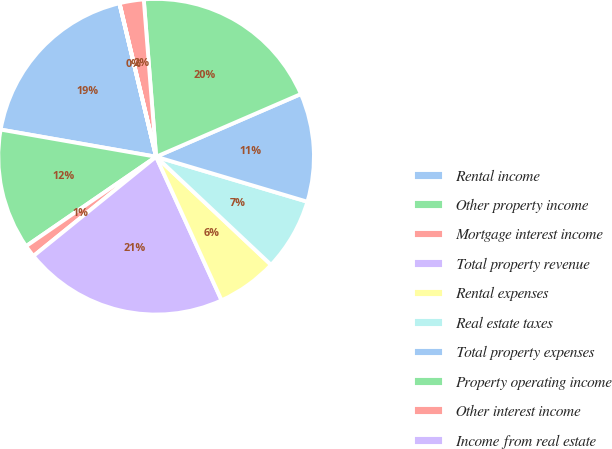Convert chart to OTSL. <chart><loc_0><loc_0><loc_500><loc_500><pie_chart><fcel>Rental income<fcel>Other property income<fcel>Mortgage interest income<fcel>Total property revenue<fcel>Rental expenses<fcel>Real estate taxes<fcel>Total property expenses<fcel>Property operating income<fcel>Other interest income<fcel>Income from real estate<nl><fcel>18.51%<fcel>12.34%<fcel>1.24%<fcel>20.98%<fcel>6.18%<fcel>7.41%<fcel>11.11%<fcel>19.74%<fcel>2.48%<fcel>0.01%<nl></chart> 